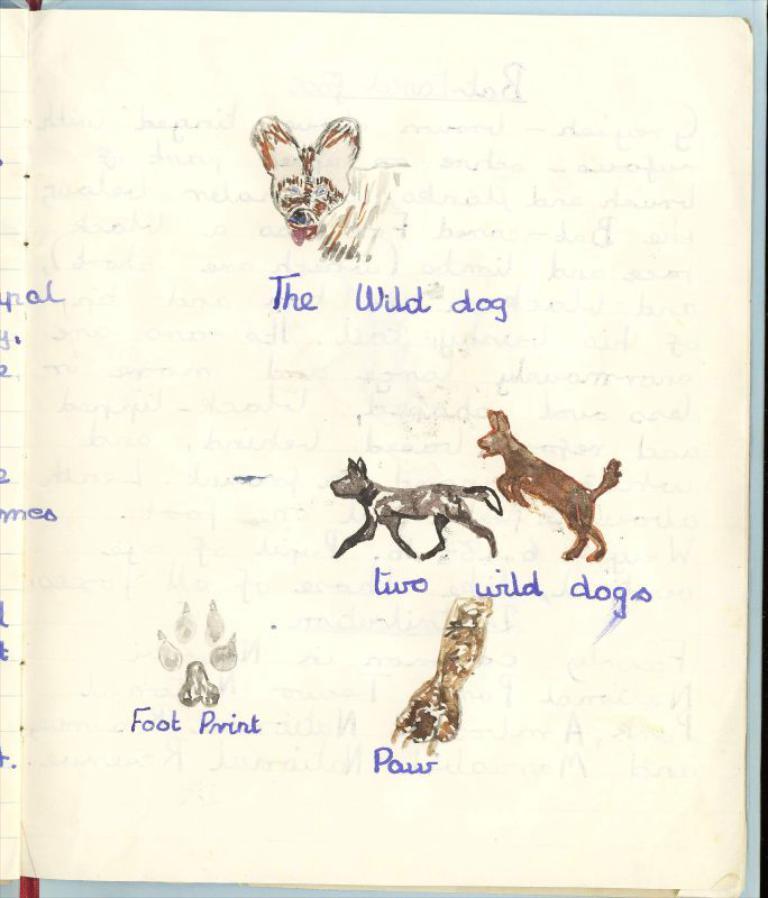In one or two sentences, can you explain what this image depicts? In this image there is a book on the book there is a depiction of some animals and there is text. 